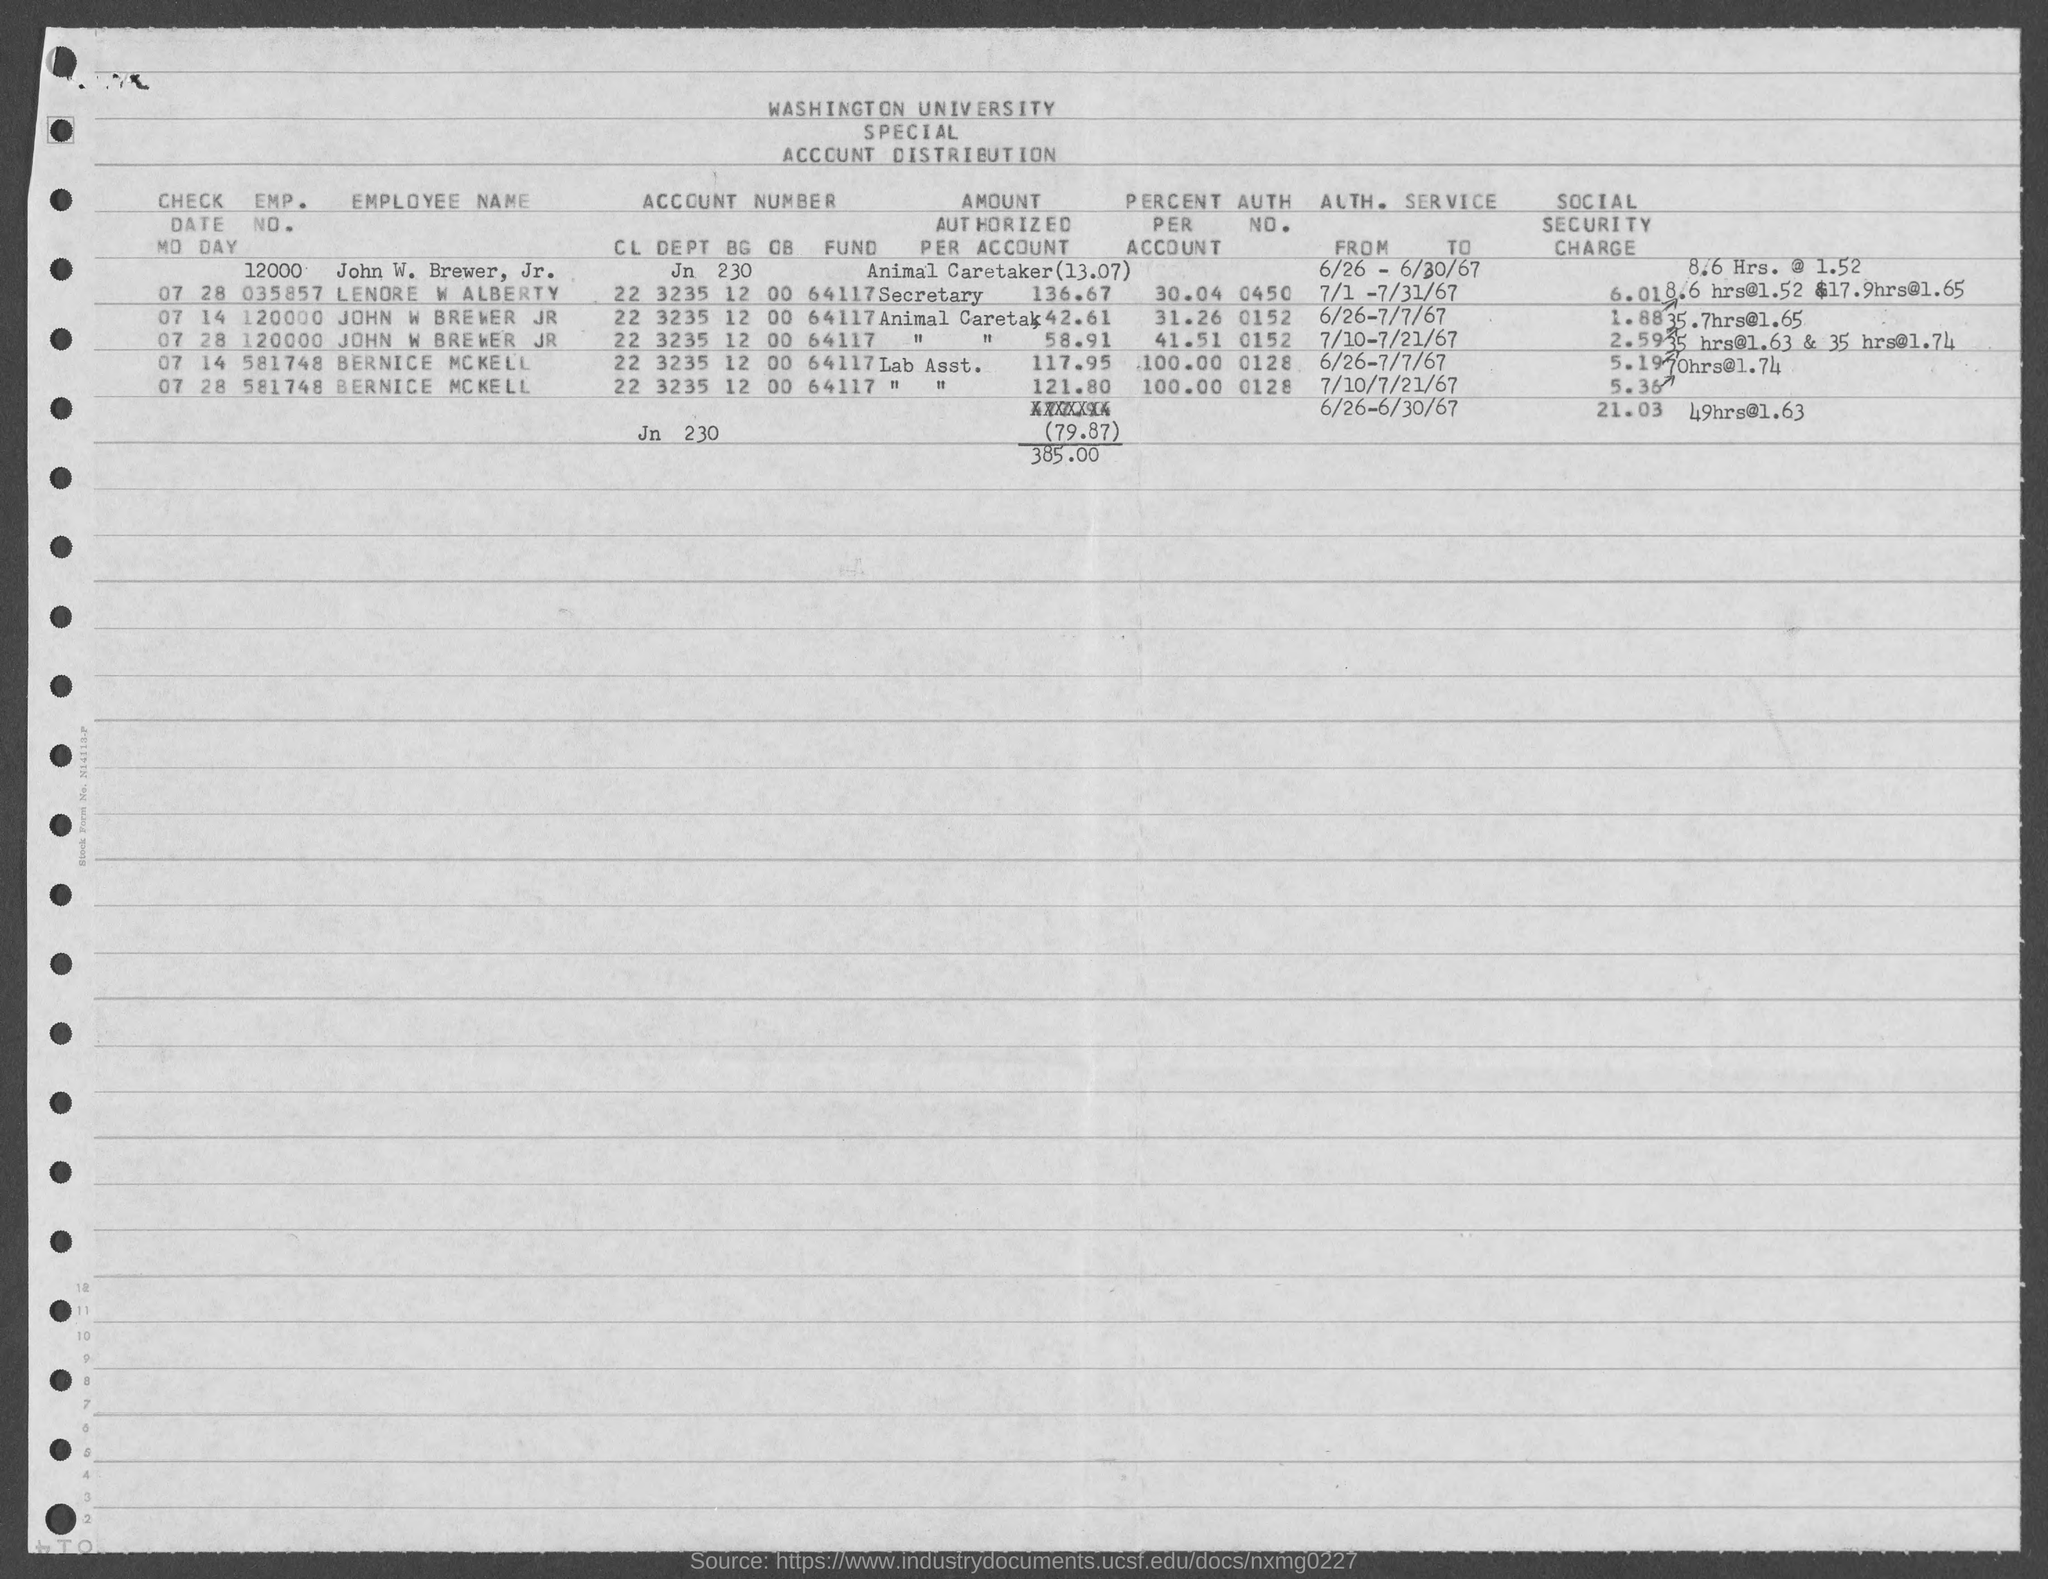What is the emp. no. of bernice mckell as mentioned in the given form ?
Your answer should be very brief. 581748. What is the auth. no. for lenore w alberty ?
Your response must be concise. 0450. What is the auth. no. for john w brewer jr. ?
Your answer should be very brief. 0152. What is the auth. no. for bernice mckell ?
Ensure brevity in your answer.  0128. What is the value of percent per account for lenore w alberty as mentioned in the given form ?
Keep it short and to the point. 30.04. What is the value of percent per account for bernice mckell as mentioned in the given form ?
Ensure brevity in your answer.  100. 